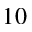Convert formula to latex. <formula><loc_0><loc_0><loc_500><loc_500>1 0</formula> 